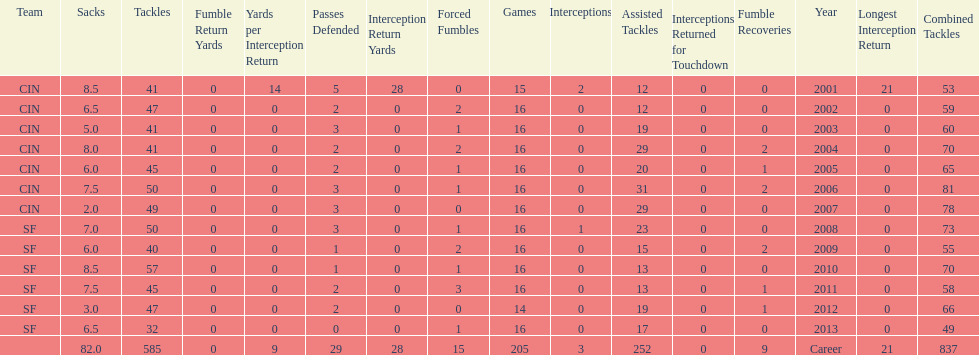How many years did he play in less than 16 games? 2. 